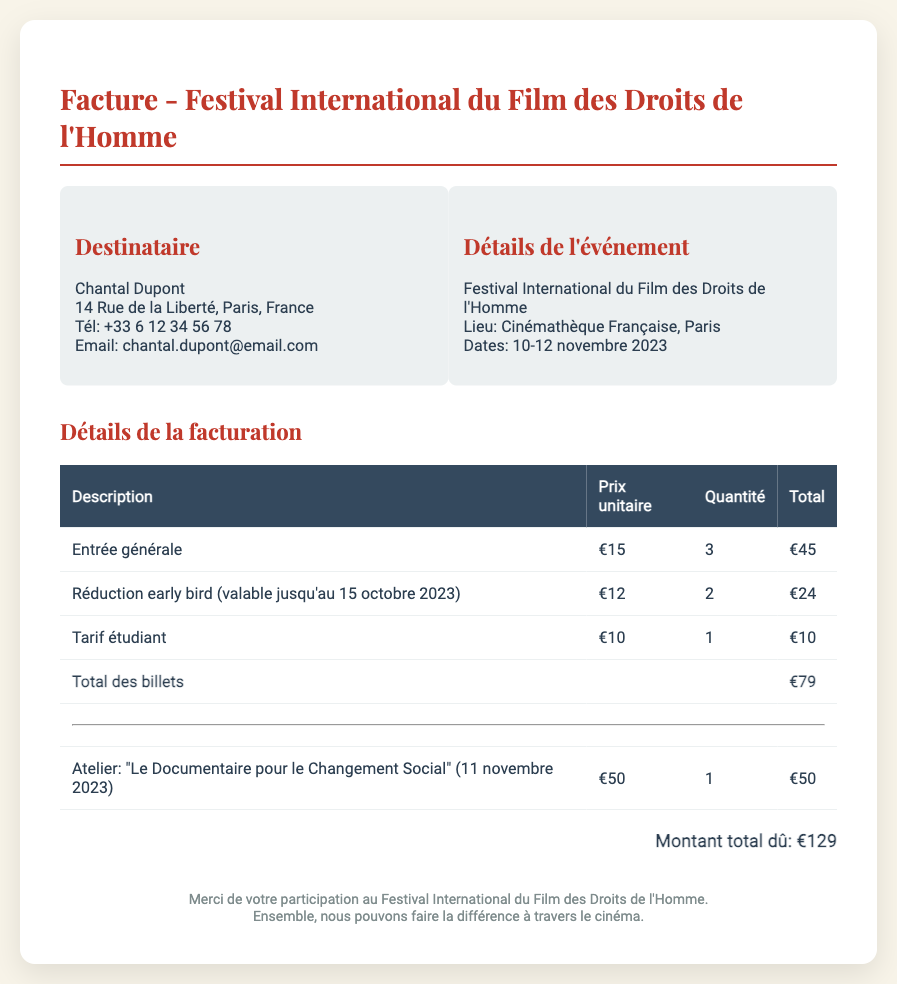Quel est le montant total dû? Le montant total dû est indiqué à la fin de la facture.
Answer: €129 Quelle est la date limite pour bénéficier de la réduction early bird? La réduction early bird est valable jusqu'au 15 octobre 2023, mentionnée dans le document.
Answer: 15 octobre 2023 Quel est le prix unitaire d'un tarif étudiant? Le prix unitaire d'un tarif étudiant est spécifié dans le tableau de facturation.
Answer: €10 Combien de billets d'entrée générale ont été achetés? Le nombre de billets d'entrée générale est précisé dans la section de facturation.
Answer: 3 Quel atelier est proposé durant le festival? Le document mentionne un atelier spécifique avec son titre et sa date.
Answer: "Le Documentaire pour le Changement Social" Quel est le total des billets avant l'atelier? Le total des billets est calculé en additionnant les différents types de billets.
Answer: €79 Quel est le lieu du festival? Le lieu de l'événement est spécifié dans les détails de l'événement dans le document.
Answer: Cinémathèque Française Quel est le prix de l'atelier? Le prix de l'atelier est énoncé dans la section correspondante de la facture.
Answer: €50 Qui est le destinataire de cette facture? Le destinataire est mentionné en haut de la facture.
Answer: Chantal Dupont 